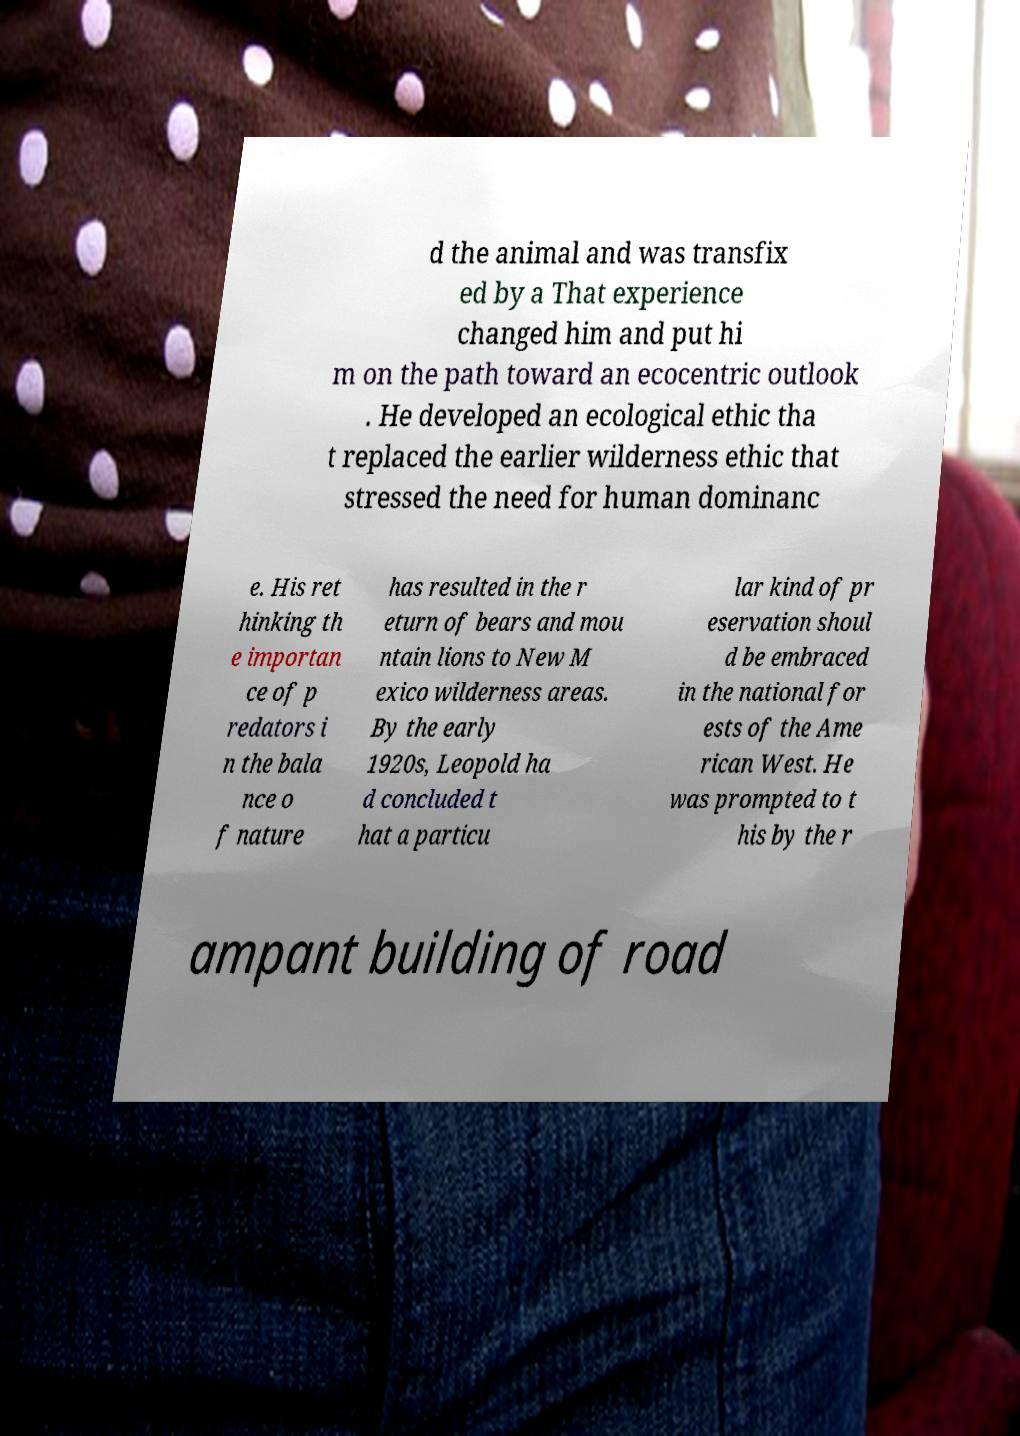There's text embedded in this image that I need extracted. Can you transcribe it verbatim? d the animal and was transfix ed by a That experience changed him and put hi m on the path toward an ecocentric outlook . He developed an ecological ethic tha t replaced the earlier wilderness ethic that stressed the need for human dominanc e. His ret hinking th e importan ce of p redators i n the bala nce o f nature has resulted in the r eturn of bears and mou ntain lions to New M exico wilderness areas. By the early 1920s, Leopold ha d concluded t hat a particu lar kind of pr eservation shoul d be embraced in the national for ests of the Ame rican West. He was prompted to t his by the r ampant building of road 